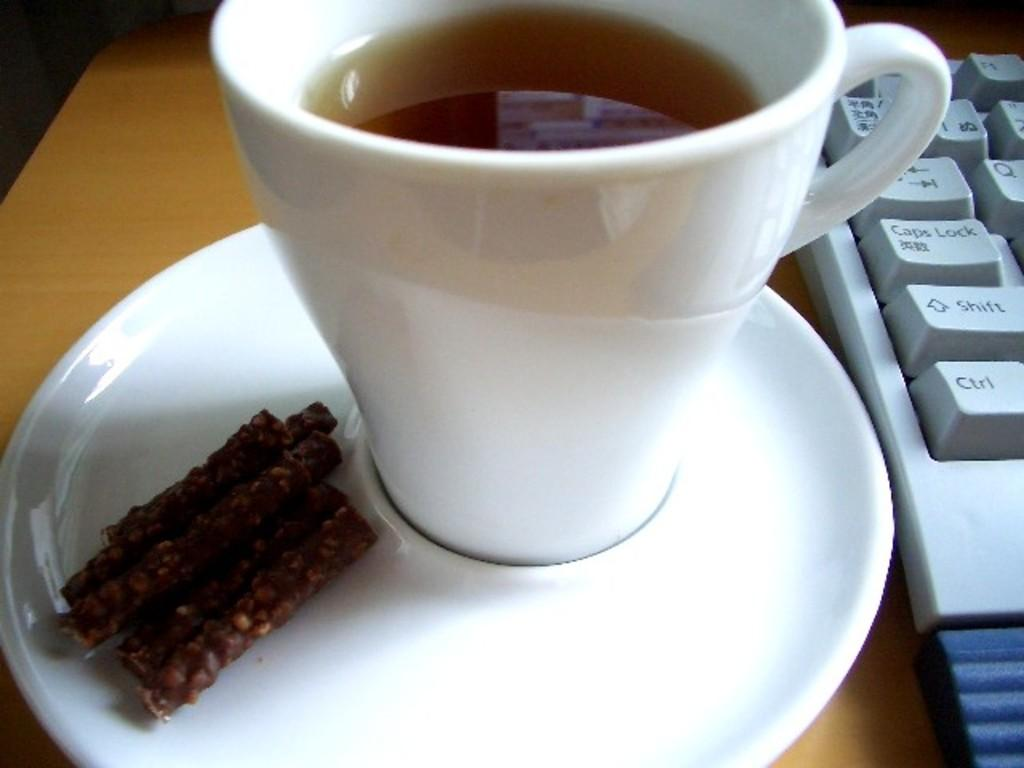What type of container is holding a drink in the image? There is a white cup of drink in the image. What else can be seen in the image besides the cup of drink? There is a food item and a white plate in the image. Where is the keyboard located in the image? The keyboard is on the right side of the image. What is the keyboard placed on? The keyboard is on a wooden surface. How does the beginner feel while participating in the thrilling battle in the image? There is no reference to a beginner, thrilling battle, or any emotions in the image. The image features a white cup of drink, a food item, a white plate, and a white keyboard on a wooden surface. 